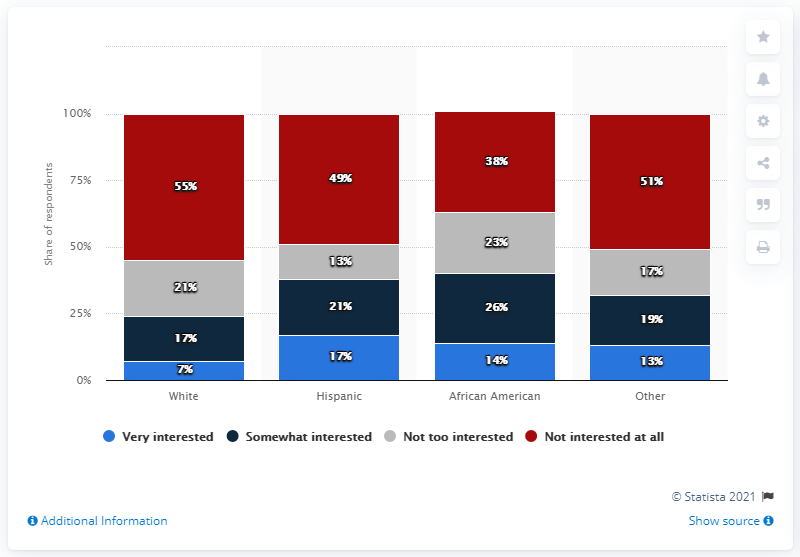Identify some key points in this picture. The average of all people who are very interested is 12.75. According to the survey, 55% of white respondents stated that they had no interest in soccer. According to a survey conducted in 2020, white respondents reported having a high level of interest in soccer, with 70% of them stating that they were very interested in the sport. There is a high level of interest in soccer among individuals of Hispanic descent, with 17% of this group expressing a strong interest in the sport. 